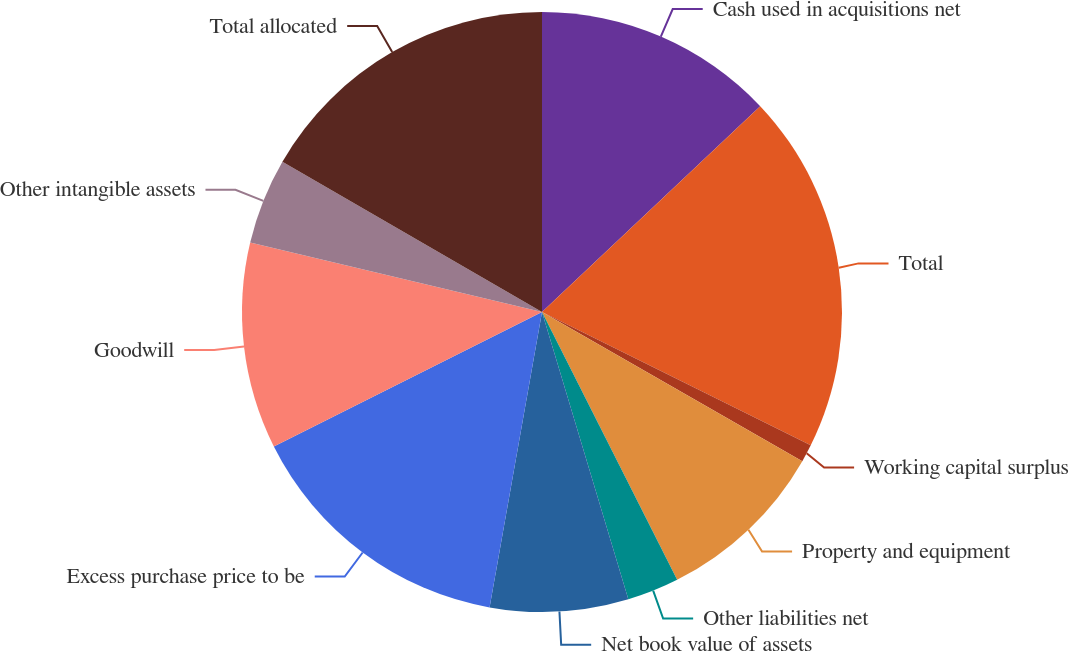Convert chart to OTSL. <chart><loc_0><loc_0><loc_500><loc_500><pie_chart><fcel>Cash used in acquisitions net<fcel>Total<fcel>Working capital surplus<fcel>Property and equipment<fcel>Other liabilities net<fcel>Net book value of assets<fcel>Excess purchase price to be<fcel>Goodwill<fcel>Other intangible assets<fcel>Total allocated<nl><fcel>12.96%<fcel>19.36%<fcel>0.95%<fcel>9.28%<fcel>2.79%<fcel>7.44%<fcel>14.8%<fcel>11.12%<fcel>4.63%<fcel>16.64%<nl></chart> 